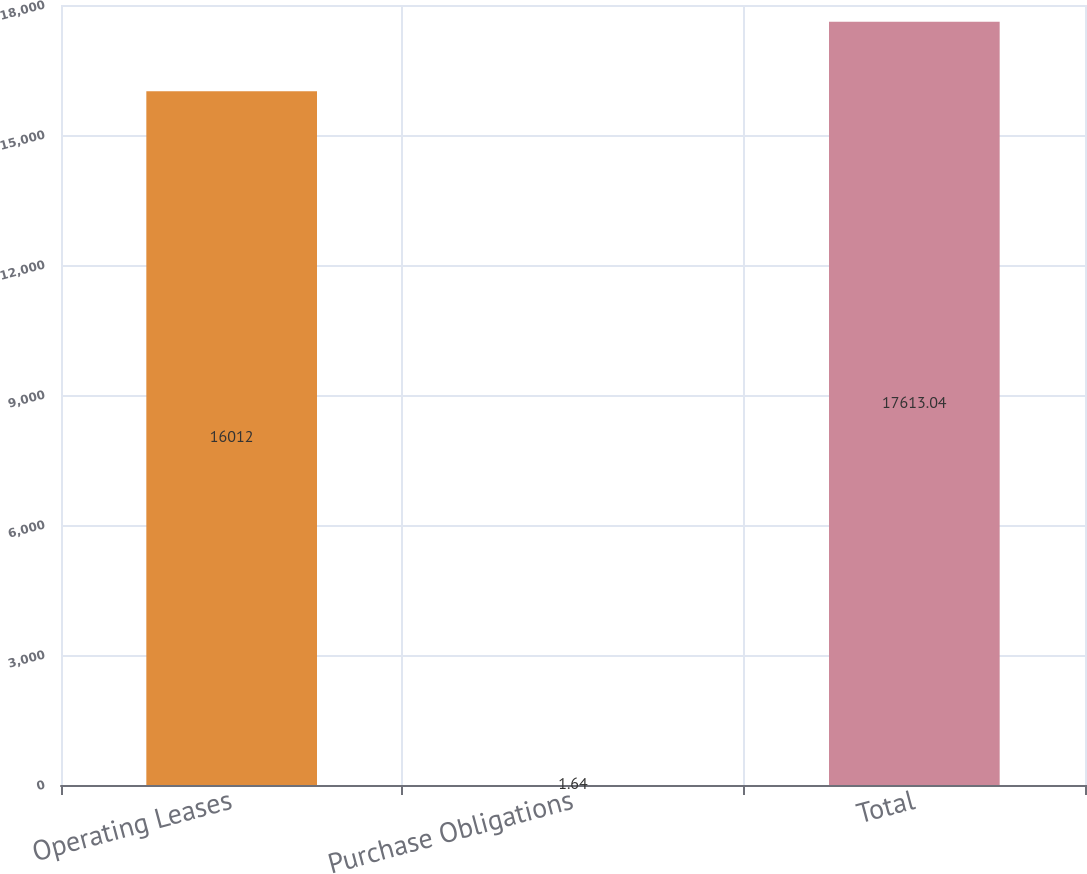<chart> <loc_0><loc_0><loc_500><loc_500><bar_chart><fcel>Operating Leases<fcel>Purchase Obligations<fcel>Total<nl><fcel>16012<fcel>1.64<fcel>17613<nl></chart> 